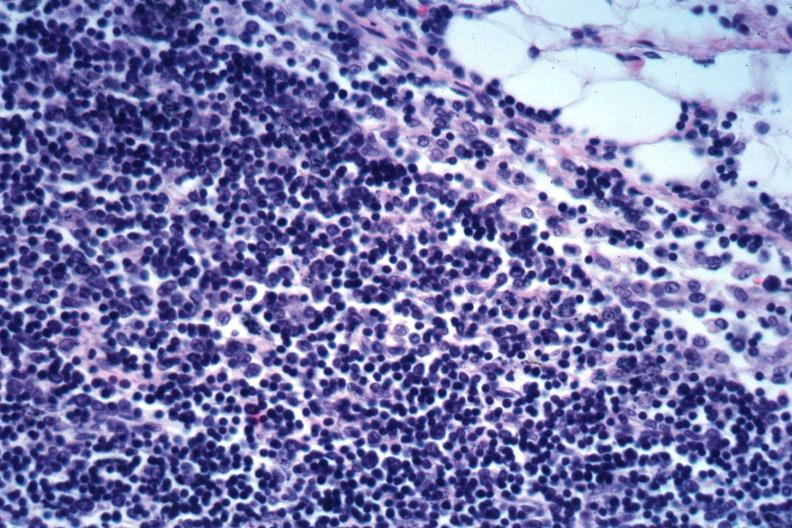s lymph node present?
Answer the question using a single word or phrase. Yes 